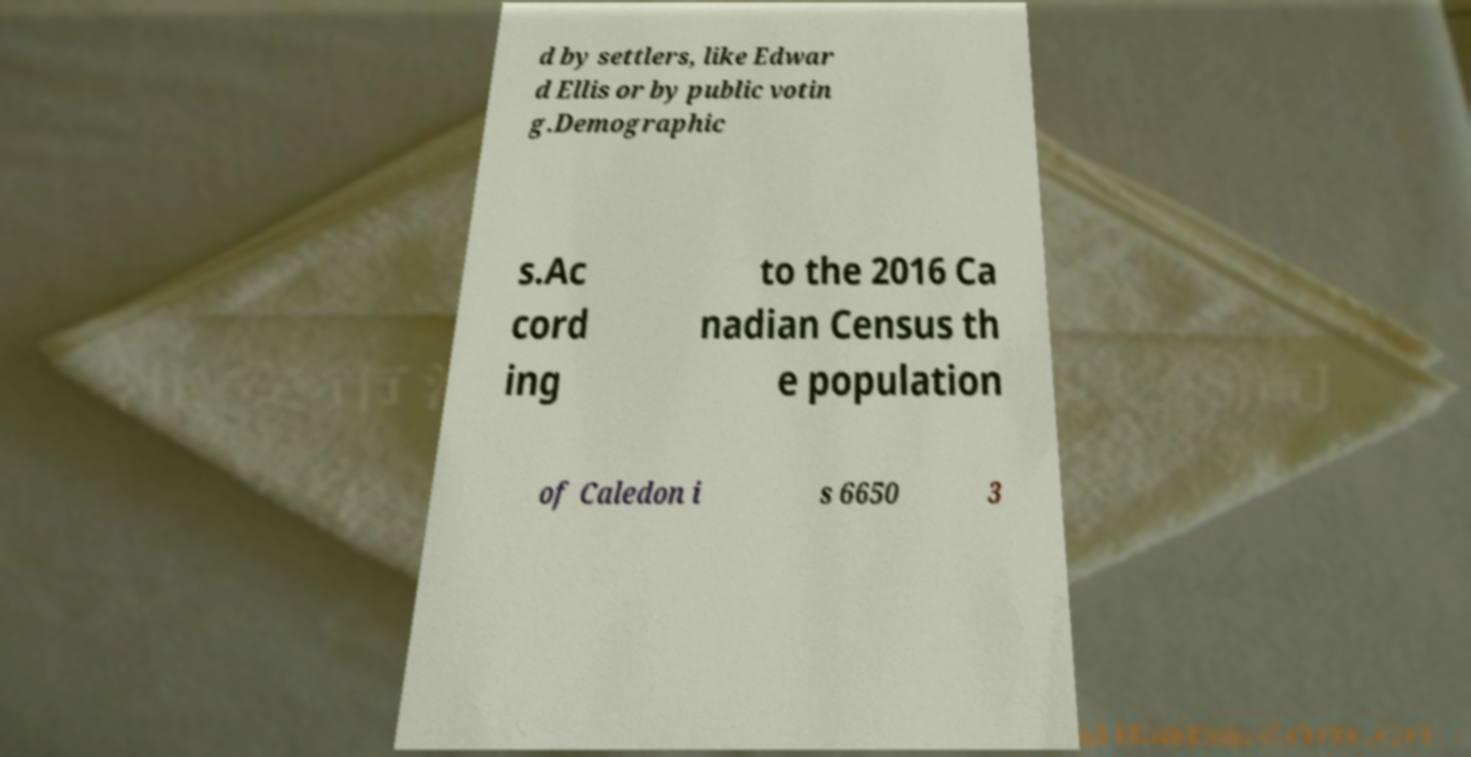Can you read and provide the text displayed in the image?This photo seems to have some interesting text. Can you extract and type it out for me? d by settlers, like Edwar d Ellis or by public votin g.Demographic s.Ac cord ing to the 2016 Ca nadian Census th e population of Caledon i s 6650 3 